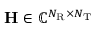Convert formula to latex. <formula><loc_0><loc_0><loc_500><loc_500>H \in \mathbb { C } ^ { N _ { R } \times N _ { T } }</formula> 